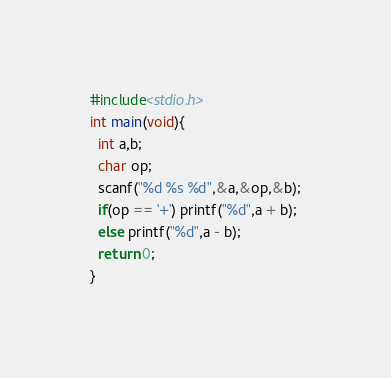Convert code to text. <code><loc_0><loc_0><loc_500><loc_500><_C_>#include<stdio.h>
int main(void){
  int a,b;
  char op;
  scanf("%d %s %d",&a,&op,&b);
  if(op == '+') printf("%d",a + b);
  else printf("%d",a - b);
  return 0;
}</code> 